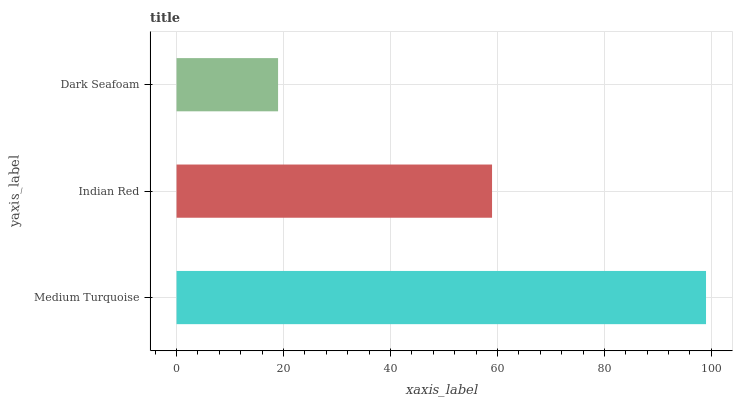Is Dark Seafoam the minimum?
Answer yes or no. Yes. Is Medium Turquoise the maximum?
Answer yes or no. Yes. Is Indian Red the minimum?
Answer yes or no. No. Is Indian Red the maximum?
Answer yes or no. No. Is Medium Turquoise greater than Indian Red?
Answer yes or no. Yes. Is Indian Red less than Medium Turquoise?
Answer yes or no. Yes. Is Indian Red greater than Medium Turquoise?
Answer yes or no. No. Is Medium Turquoise less than Indian Red?
Answer yes or no. No. Is Indian Red the high median?
Answer yes or no. Yes. Is Indian Red the low median?
Answer yes or no. Yes. Is Medium Turquoise the high median?
Answer yes or no. No. Is Medium Turquoise the low median?
Answer yes or no. No. 